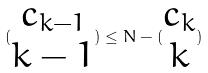Convert formula to latex. <formula><loc_0><loc_0><loc_500><loc_500>( \begin{matrix} c _ { k - 1 } \\ k - 1 \end{matrix} ) \leq N - ( \begin{matrix} c _ { k } \\ k \end{matrix} )</formula> 